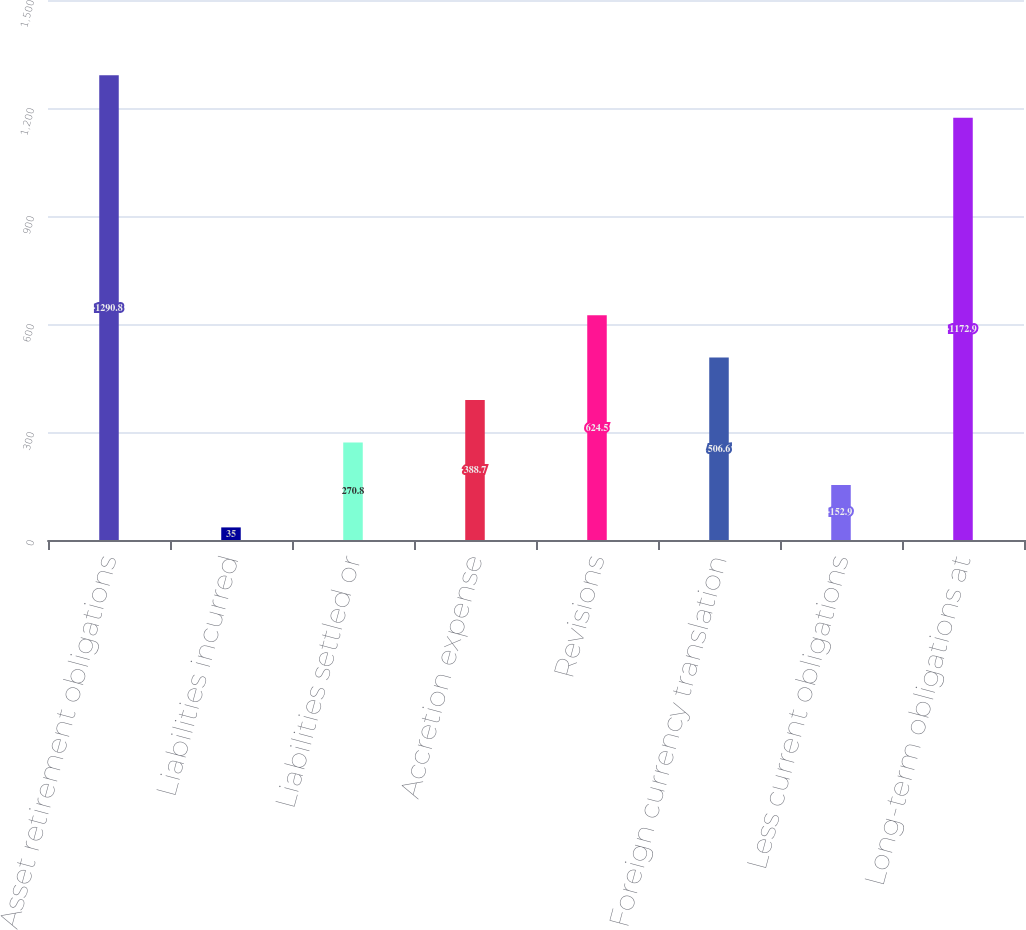Convert chart to OTSL. <chart><loc_0><loc_0><loc_500><loc_500><bar_chart><fcel>Asset retirement obligations<fcel>Liabilities incurred<fcel>Liabilities settled or<fcel>Accretion expense<fcel>Revisions<fcel>Foreign currency translation<fcel>Less current obligations<fcel>Long-term obligations at<nl><fcel>1290.8<fcel>35<fcel>270.8<fcel>388.7<fcel>624.5<fcel>506.6<fcel>152.9<fcel>1172.9<nl></chart> 